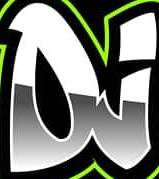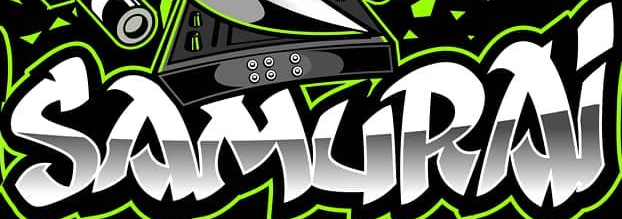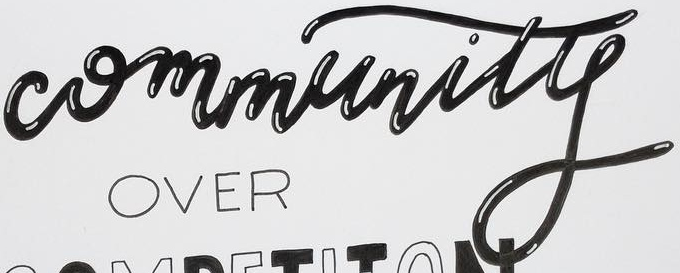Read the text from these images in sequence, separated by a semicolon. DJ; SAMURAi; Community 